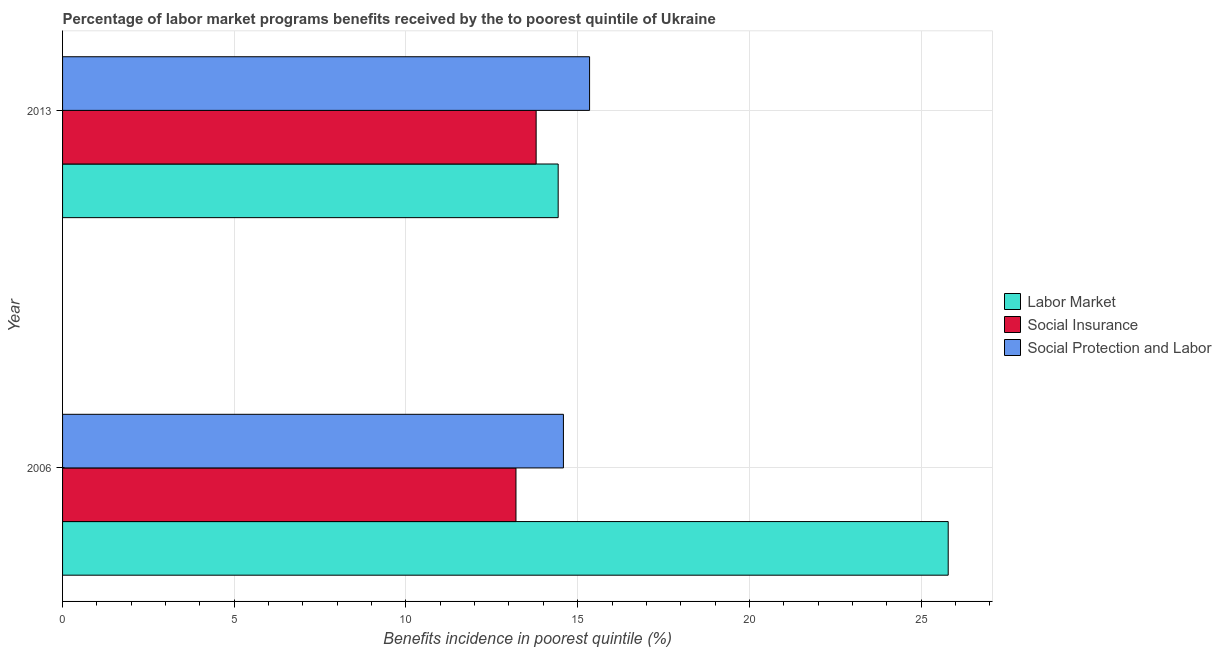Are the number of bars per tick equal to the number of legend labels?
Make the answer very short. Yes. Are the number of bars on each tick of the Y-axis equal?
Make the answer very short. Yes. How many bars are there on the 1st tick from the top?
Keep it short and to the point. 3. How many bars are there on the 1st tick from the bottom?
Your answer should be very brief. 3. What is the label of the 2nd group of bars from the top?
Your response must be concise. 2006. What is the percentage of benefits received due to social protection programs in 2013?
Make the answer very short. 15.35. Across all years, what is the maximum percentage of benefits received due to social protection programs?
Provide a short and direct response. 15.35. Across all years, what is the minimum percentage of benefits received due to labor market programs?
Ensure brevity in your answer.  14.43. In which year was the percentage of benefits received due to labor market programs minimum?
Provide a succinct answer. 2013. What is the total percentage of benefits received due to social insurance programs in the graph?
Make the answer very short. 26.99. What is the difference between the percentage of benefits received due to social insurance programs in 2006 and that in 2013?
Ensure brevity in your answer.  -0.59. What is the difference between the percentage of benefits received due to social protection programs in 2006 and the percentage of benefits received due to social insurance programs in 2013?
Ensure brevity in your answer.  0.79. What is the average percentage of benefits received due to social protection programs per year?
Your answer should be very brief. 14.97. In the year 2006, what is the difference between the percentage of benefits received due to social protection programs and percentage of benefits received due to social insurance programs?
Offer a very short reply. 1.38. What is the ratio of the percentage of benefits received due to social protection programs in 2006 to that in 2013?
Provide a succinct answer. 0.95. Is the percentage of benefits received due to labor market programs in 2006 less than that in 2013?
Offer a very short reply. No. Is the difference between the percentage of benefits received due to labor market programs in 2006 and 2013 greater than the difference between the percentage of benefits received due to social protection programs in 2006 and 2013?
Offer a terse response. Yes. What does the 2nd bar from the top in 2006 represents?
Keep it short and to the point. Social Insurance. What does the 1st bar from the bottom in 2006 represents?
Your response must be concise. Labor Market. How many bars are there?
Provide a succinct answer. 6. How many years are there in the graph?
Provide a short and direct response. 2. What is the difference between two consecutive major ticks on the X-axis?
Offer a terse response. 5. Does the graph contain any zero values?
Offer a very short reply. No. Does the graph contain grids?
Provide a short and direct response. Yes. Where does the legend appear in the graph?
Give a very brief answer. Center right. How many legend labels are there?
Provide a succinct answer. 3. What is the title of the graph?
Your response must be concise. Percentage of labor market programs benefits received by the to poorest quintile of Ukraine. What is the label or title of the X-axis?
Your response must be concise. Benefits incidence in poorest quintile (%). What is the label or title of the Y-axis?
Keep it short and to the point. Year. What is the Benefits incidence in poorest quintile (%) in Labor Market in 2006?
Make the answer very short. 25.79. What is the Benefits incidence in poorest quintile (%) of Social Insurance in 2006?
Your answer should be compact. 13.2. What is the Benefits incidence in poorest quintile (%) in Social Protection and Labor in 2006?
Provide a succinct answer. 14.59. What is the Benefits incidence in poorest quintile (%) of Labor Market in 2013?
Offer a terse response. 14.43. What is the Benefits incidence in poorest quintile (%) in Social Insurance in 2013?
Provide a short and direct response. 13.79. What is the Benefits incidence in poorest quintile (%) of Social Protection and Labor in 2013?
Offer a very short reply. 15.35. Across all years, what is the maximum Benefits incidence in poorest quintile (%) in Labor Market?
Keep it short and to the point. 25.79. Across all years, what is the maximum Benefits incidence in poorest quintile (%) in Social Insurance?
Keep it short and to the point. 13.79. Across all years, what is the maximum Benefits incidence in poorest quintile (%) in Social Protection and Labor?
Ensure brevity in your answer.  15.35. Across all years, what is the minimum Benefits incidence in poorest quintile (%) of Labor Market?
Your answer should be very brief. 14.43. Across all years, what is the minimum Benefits incidence in poorest quintile (%) of Social Insurance?
Keep it short and to the point. 13.2. Across all years, what is the minimum Benefits incidence in poorest quintile (%) of Social Protection and Labor?
Your response must be concise. 14.59. What is the total Benefits incidence in poorest quintile (%) of Labor Market in the graph?
Ensure brevity in your answer.  40.22. What is the total Benefits incidence in poorest quintile (%) of Social Insurance in the graph?
Make the answer very short. 26.99. What is the total Benefits incidence in poorest quintile (%) of Social Protection and Labor in the graph?
Provide a short and direct response. 29.93. What is the difference between the Benefits incidence in poorest quintile (%) of Labor Market in 2006 and that in 2013?
Provide a short and direct response. 11.36. What is the difference between the Benefits incidence in poorest quintile (%) of Social Insurance in 2006 and that in 2013?
Offer a very short reply. -0.59. What is the difference between the Benefits incidence in poorest quintile (%) in Social Protection and Labor in 2006 and that in 2013?
Keep it short and to the point. -0.76. What is the difference between the Benefits incidence in poorest quintile (%) in Labor Market in 2006 and the Benefits incidence in poorest quintile (%) in Social Insurance in 2013?
Your answer should be compact. 12. What is the difference between the Benefits incidence in poorest quintile (%) of Labor Market in 2006 and the Benefits incidence in poorest quintile (%) of Social Protection and Labor in 2013?
Provide a short and direct response. 10.44. What is the difference between the Benefits incidence in poorest quintile (%) of Social Insurance in 2006 and the Benefits incidence in poorest quintile (%) of Social Protection and Labor in 2013?
Offer a terse response. -2.14. What is the average Benefits incidence in poorest quintile (%) in Labor Market per year?
Offer a very short reply. 20.11. What is the average Benefits incidence in poorest quintile (%) of Social Insurance per year?
Your answer should be compact. 13.5. What is the average Benefits incidence in poorest quintile (%) of Social Protection and Labor per year?
Your response must be concise. 14.97. In the year 2006, what is the difference between the Benefits incidence in poorest quintile (%) in Labor Market and Benefits incidence in poorest quintile (%) in Social Insurance?
Offer a very short reply. 12.59. In the year 2006, what is the difference between the Benefits incidence in poorest quintile (%) in Labor Market and Benefits incidence in poorest quintile (%) in Social Protection and Labor?
Your response must be concise. 11.21. In the year 2006, what is the difference between the Benefits incidence in poorest quintile (%) in Social Insurance and Benefits incidence in poorest quintile (%) in Social Protection and Labor?
Your answer should be very brief. -1.38. In the year 2013, what is the difference between the Benefits incidence in poorest quintile (%) in Labor Market and Benefits incidence in poorest quintile (%) in Social Insurance?
Ensure brevity in your answer.  0.64. In the year 2013, what is the difference between the Benefits incidence in poorest quintile (%) in Labor Market and Benefits incidence in poorest quintile (%) in Social Protection and Labor?
Ensure brevity in your answer.  -0.91. In the year 2013, what is the difference between the Benefits incidence in poorest quintile (%) of Social Insurance and Benefits incidence in poorest quintile (%) of Social Protection and Labor?
Your answer should be compact. -1.56. What is the ratio of the Benefits incidence in poorest quintile (%) of Labor Market in 2006 to that in 2013?
Your answer should be very brief. 1.79. What is the ratio of the Benefits incidence in poorest quintile (%) in Social Insurance in 2006 to that in 2013?
Keep it short and to the point. 0.96. What is the ratio of the Benefits incidence in poorest quintile (%) of Social Protection and Labor in 2006 to that in 2013?
Your answer should be compact. 0.95. What is the difference between the highest and the second highest Benefits incidence in poorest quintile (%) of Labor Market?
Your response must be concise. 11.36. What is the difference between the highest and the second highest Benefits incidence in poorest quintile (%) of Social Insurance?
Your answer should be very brief. 0.59. What is the difference between the highest and the second highest Benefits incidence in poorest quintile (%) in Social Protection and Labor?
Ensure brevity in your answer.  0.76. What is the difference between the highest and the lowest Benefits incidence in poorest quintile (%) in Labor Market?
Offer a very short reply. 11.36. What is the difference between the highest and the lowest Benefits incidence in poorest quintile (%) in Social Insurance?
Your answer should be compact. 0.59. What is the difference between the highest and the lowest Benefits incidence in poorest quintile (%) in Social Protection and Labor?
Ensure brevity in your answer.  0.76. 